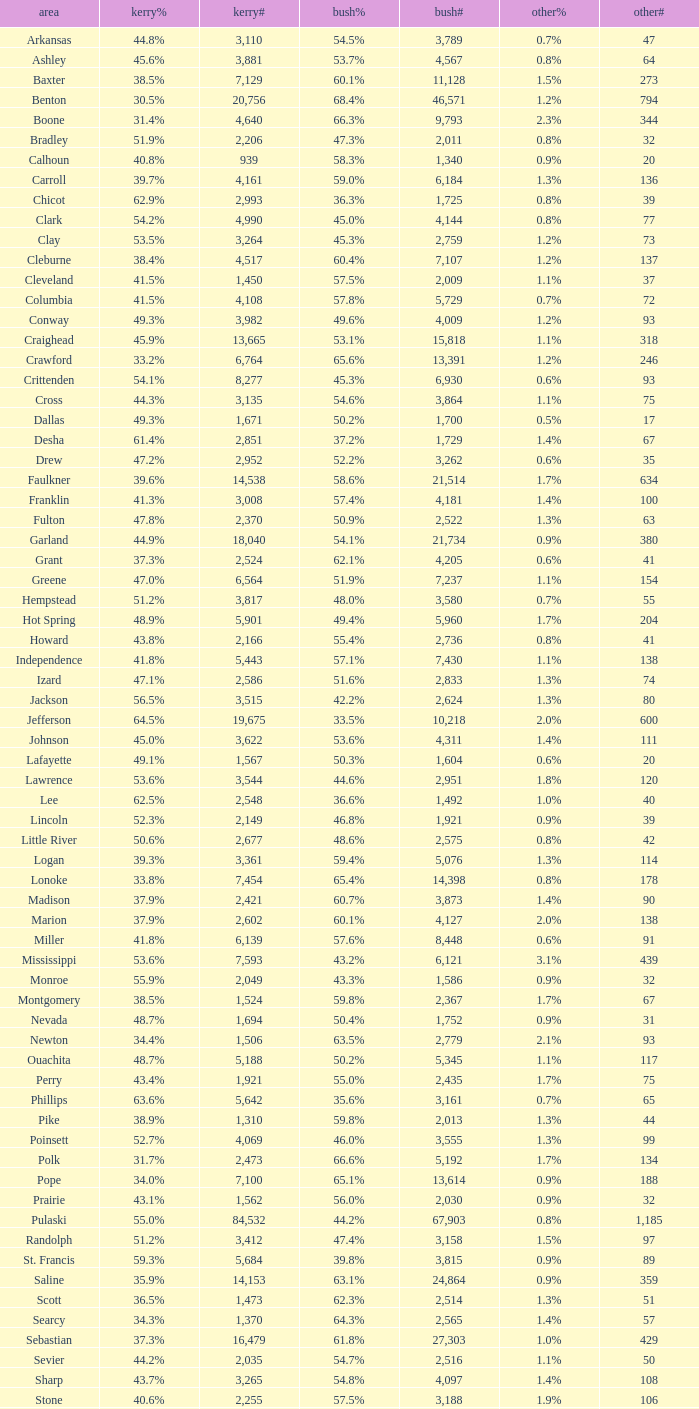7%", when others# is lesser than 75, and when kerry# is over 1,524? None. 